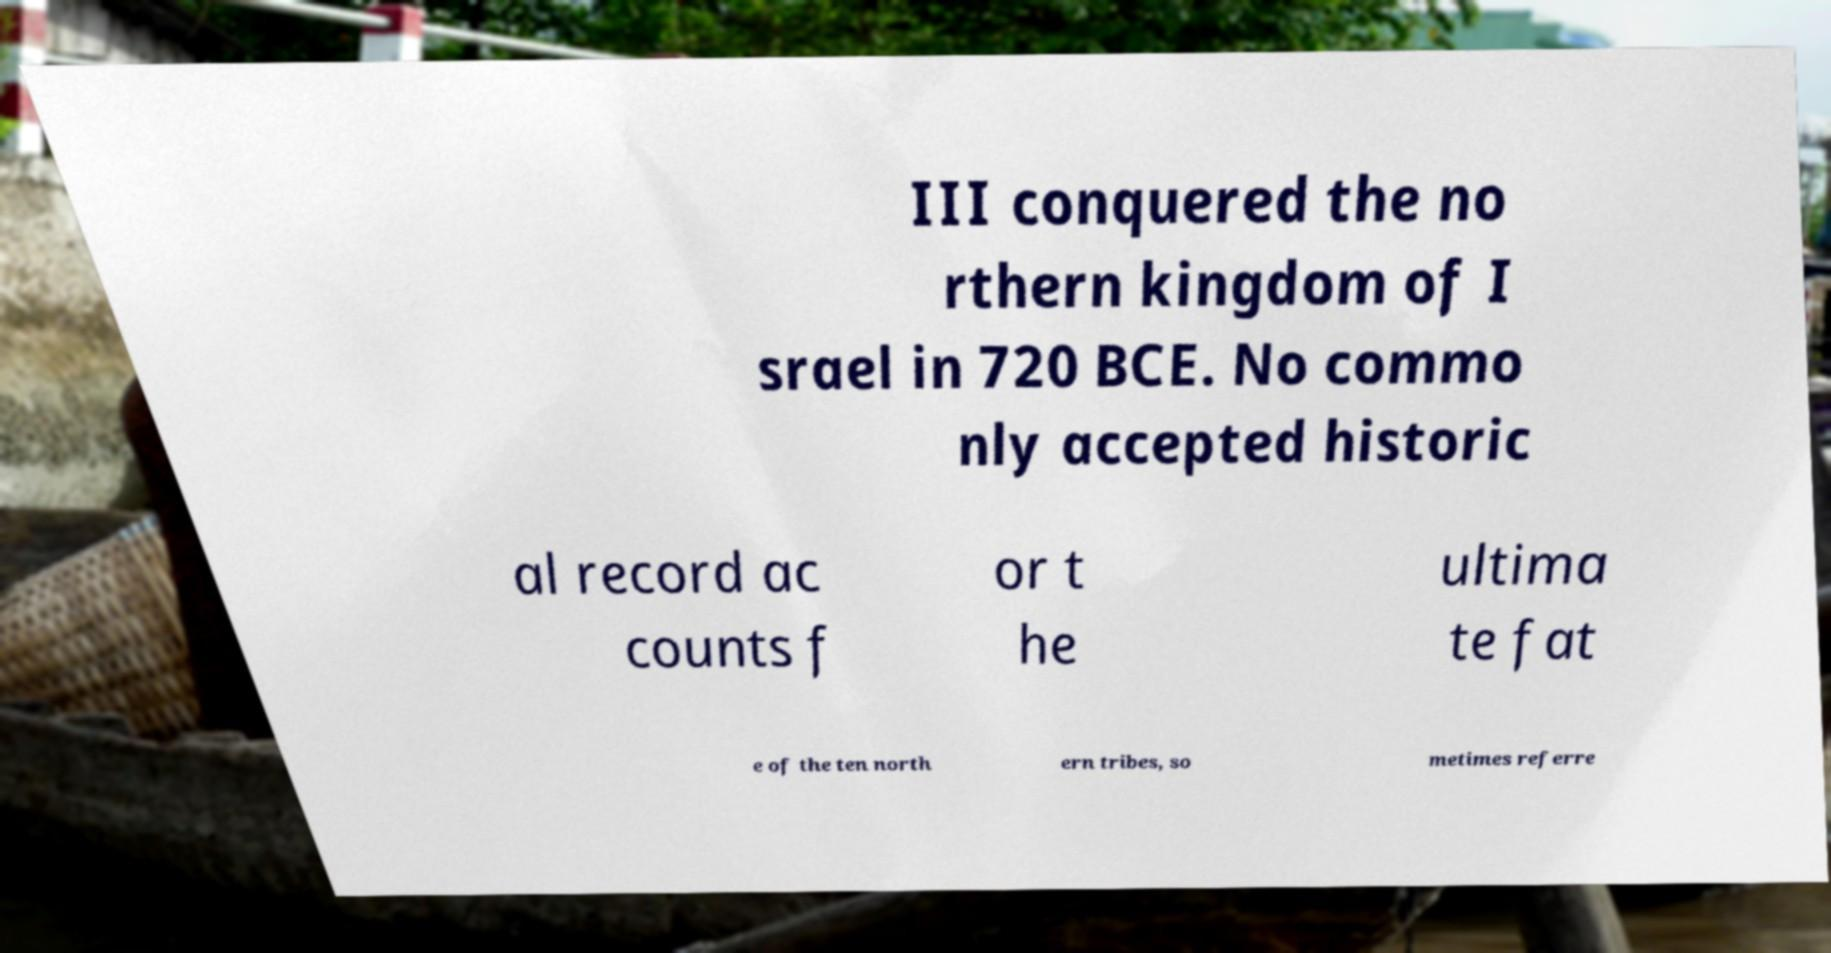Can you accurately transcribe the text from the provided image for me? III conquered the no rthern kingdom of I srael in 720 BCE. No commo nly accepted historic al record ac counts f or t he ultima te fat e of the ten north ern tribes, so metimes referre 